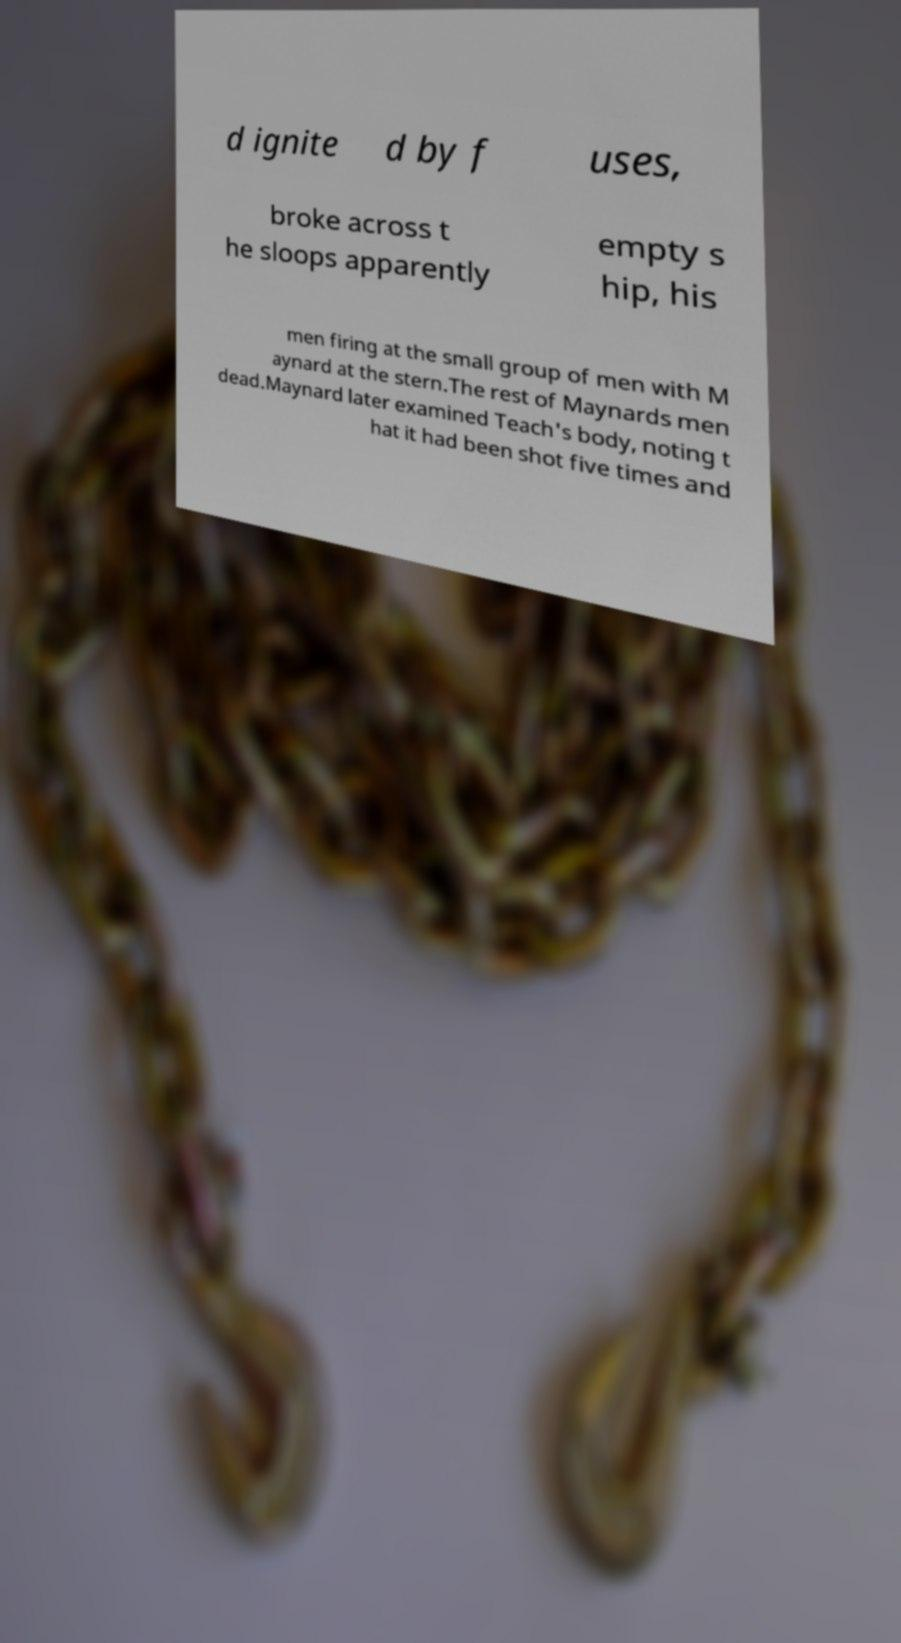Please read and relay the text visible in this image. What does it say? d ignite d by f uses, broke across t he sloops apparently empty s hip, his men firing at the small group of men with M aynard at the stern.The rest of Maynards men dead.Maynard later examined Teach's body, noting t hat it had been shot five times and 